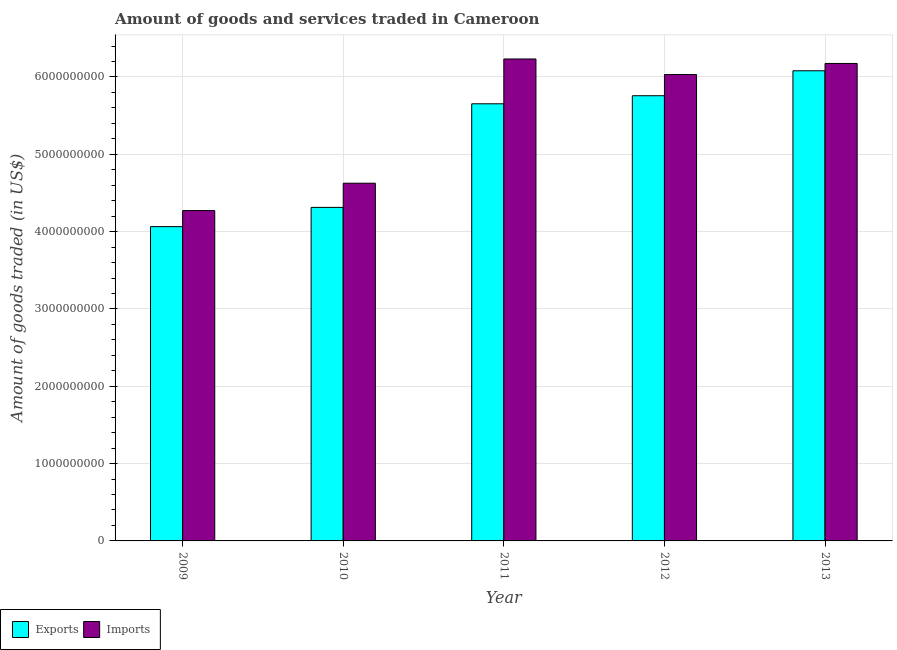How many different coloured bars are there?
Offer a terse response. 2. How many groups of bars are there?
Ensure brevity in your answer.  5. Are the number of bars per tick equal to the number of legend labels?
Your answer should be compact. Yes. Are the number of bars on each tick of the X-axis equal?
Offer a very short reply. Yes. How many bars are there on the 5th tick from the left?
Your answer should be very brief. 2. What is the label of the 2nd group of bars from the left?
Keep it short and to the point. 2010. What is the amount of goods exported in 2009?
Provide a short and direct response. 4.06e+09. Across all years, what is the maximum amount of goods imported?
Your answer should be very brief. 6.23e+09. Across all years, what is the minimum amount of goods imported?
Offer a terse response. 4.27e+09. What is the total amount of goods exported in the graph?
Offer a very short reply. 2.59e+1. What is the difference between the amount of goods imported in 2012 and that in 2013?
Provide a succinct answer. -1.43e+08. What is the difference between the amount of goods exported in 2011 and the amount of goods imported in 2009?
Provide a short and direct response. 1.59e+09. What is the average amount of goods exported per year?
Give a very brief answer. 5.17e+09. What is the ratio of the amount of goods exported in 2010 to that in 2012?
Your response must be concise. 0.75. Is the amount of goods exported in 2009 less than that in 2013?
Your answer should be very brief. Yes. What is the difference between the highest and the second highest amount of goods imported?
Provide a short and direct response. 5.81e+07. What is the difference between the highest and the lowest amount of goods exported?
Offer a very short reply. 2.02e+09. Is the sum of the amount of goods imported in 2012 and 2013 greater than the maximum amount of goods exported across all years?
Your answer should be very brief. Yes. What does the 2nd bar from the left in 2011 represents?
Your answer should be very brief. Imports. What does the 1st bar from the right in 2009 represents?
Your answer should be very brief. Imports. How many bars are there?
Keep it short and to the point. 10. What is the difference between two consecutive major ticks on the Y-axis?
Offer a terse response. 1.00e+09. Where does the legend appear in the graph?
Offer a terse response. Bottom left. What is the title of the graph?
Offer a terse response. Amount of goods and services traded in Cameroon. Does "Quality of trade" appear as one of the legend labels in the graph?
Ensure brevity in your answer.  No. What is the label or title of the Y-axis?
Make the answer very short. Amount of goods traded (in US$). What is the Amount of goods traded (in US$) of Exports in 2009?
Your answer should be compact. 4.06e+09. What is the Amount of goods traded (in US$) of Imports in 2009?
Your response must be concise. 4.27e+09. What is the Amount of goods traded (in US$) of Exports in 2010?
Make the answer very short. 4.31e+09. What is the Amount of goods traded (in US$) of Imports in 2010?
Your answer should be compact. 4.63e+09. What is the Amount of goods traded (in US$) of Exports in 2011?
Ensure brevity in your answer.  5.65e+09. What is the Amount of goods traded (in US$) of Imports in 2011?
Make the answer very short. 6.23e+09. What is the Amount of goods traded (in US$) of Exports in 2012?
Your answer should be compact. 5.76e+09. What is the Amount of goods traded (in US$) in Imports in 2012?
Your response must be concise. 6.03e+09. What is the Amount of goods traded (in US$) of Exports in 2013?
Offer a terse response. 6.08e+09. What is the Amount of goods traded (in US$) of Imports in 2013?
Offer a terse response. 6.17e+09. Across all years, what is the maximum Amount of goods traded (in US$) in Exports?
Ensure brevity in your answer.  6.08e+09. Across all years, what is the maximum Amount of goods traded (in US$) of Imports?
Give a very brief answer. 6.23e+09. Across all years, what is the minimum Amount of goods traded (in US$) in Exports?
Offer a terse response. 4.06e+09. Across all years, what is the minimum Amount of goods traded (in US$) in Imports?
Offer a terse response. 4.27e+09. What is the total Amount of goods traded (in US$) of Exports in the graph?
Offer a very short reply. 2.59e+1. What is the total Amount of goods traded (in US$) in Imports in the graph?
Provide a short and direct response. 2.73e+1. What is the difference between the Amount of goods traded (in US$) of Exports in 2009 and that in 2010?
Your response must be concise. -2.49e+08. What is the difference between the Amount of goods traded (in US$) of Imports in 2009 and that in 2010?
Ensure brevity in your answer.  -3.54e+08. What is the difference between the Amount of goods traded (in US$) of Exports in 2009 and that in 2011?
Provide a short and direct response. -1.59e+09. What is the difference between the Amount of goods traded (in US$) in Imports in 2009 and that in 2011?
Give a very brief answer. -1.96e+09. What is the difference between the Amount of goods traded (in US$) in Exports in 2009 and that in 2012?
Your answer should be very brief. -1.69e+09. What is the difference between the Amount of goods traded (in US$) of Imports in 2009 and that in 2012?
Provide a succinct answer. -1.76e+09. What is the difference between the Amount of goods traded (in US$) of Exports in 2009 and that in 2013?
Make the answer very short. -2.02e+09. What is the difference between the Amount of goods traded (in US$) of Imports in 2009 and that in 2013?
Give a very brief answer. -1.90e+09. What is the difference between the Amount of goods traded (in US$) in Exports in 2010 and that in 2011?
Your response must be concise. -1.34e+09. What is the difference between the Amount of goods traded (in US$) in Imports in 2010 and that in 2011?
Provide a succinct answer. -1.61e+09. What is the difference between the Amount of goods traded (in US$) of Exports in 2010 and that in 2012?
Provide a short and direct response. -1.44e+09. What is the difference between the Amount of goods traded (in US$) of Imports in 2010 and that in 2012?
Keep it short and to the point. -1.41e+09. What is the difference between the Amount of goods traded (in US$) in Exports in 2010 and that in 2013?
Give a very brief answer. -1.77e+09. What is the difference between the Amount of goods traded (in US$) of Imports in 2010 and that in 2013?
Give a very brief answer. -1.55e+09. What is the difference between the Amount of goods traded (in US$) of Exports in 2011 and that in 2012?
Your answer should be compact. -1.04e+08. What is the difference between the Amount of goods traded (in US$) of Imports in 2011 and that in 2012?
Give a very brief answer. 2.01e+08. What is the difference between the Amount of goods traded (in US$) of Exports in 2011 and that in 2013?
Offer a terse response. -4.27e+08. What is the difference between the Amount of goods traded (in US$) in Imports in 2011 and that in 2013?
Offer a terse response. 5.81e+07. What is the difference between the Amount of goods traded (in US$) of Exports in 2012 and that in 2013?
Your answer should be compact. -3.23e+08. What is the difference between the Amount of goods traded (in US$) of Imports in 2012 and that in 2013?
Keep it short and to the point. -1.43e+08. What is the difference between the Amount of goods traded (in US$) in Exports in 2009 and the Amount of goods traded (in US$) in Imports in 2010?
Keep it short and to the point. -5.62e+08. What is the difference between the Amount of goods traded (in US$) of Exports in 2009 and the Amount of goods traded (in US$) of Imports in 2011?
Make the answer very short. -2.17e+09. What is the difference between the Amount of goods traded (in US$) in Exports in 2009 and the Amount of goods traded (in US$) in Imports in 2012?
Keep it short and to the point. -1.97e+09. What is the difference between the Amount of goods traded (in US$) of Exports in 2009 and the Amount of goods traded (in US$) of Imports in 2013?
Keep it short and to the point. -2.11e+09. What is the difference between the Amount of goods traded (in US$) of Exports in 2010 and the Amount of goods traded (in US$) of Imports in 2011?
Give a very brief answer. -1.92e+09. What is the difference between the Amount of goods traded (in US$) of Exports in 2010 and the Amount of goods traded (in US$) of Imports in 2012?
Provide a short and direct response. -1.72e+09. What is the difference between the Amount of goods traded (in US$) in Exports in 2010 and the Amount of goods traded (in US$) in Imports in 2013?
Keep it short and to the point. -1.86e+09. What is the difference between the Amount of goods traded (in US$) in Exports in 2011 and the Amount of goods traded (in US$) in Imports in 2012?
Offer a terse response. -3.78e+08. What is the difference between the Amount of goods traded (in US$) in Exports in 2011 and the Amount of goods traded (in US$) in Imports in 2013?
Ensure brevity in your answer.  -5.21e+08. What is the difference between the Amount of goods traded (in US$) in Exports in 2012 and the Amount of goods traded (in US$) in Imports in 2013?
Your response must be concise. -4.17e+08. What is the average Amount of goods traded (in US$) of Exports per year?
Make the answer very short. 5.17e+09. What is the average Amount of goods traded (in US$) of Imports per year?
Offer a terse response. 5.47e+09. In the year 2009, what is the difference between the Amount of goods traded (in US$) in Exports and Amount of goods traded (in US$) in Imports?
Your answer should be very brief. -2.08e+08. In the year 2010, what is the difference between the Amount of goods traded (in US$) in Exports and Amount of goods traded (in US$) in Imports?
Ensure brevity in your answer.  -3.13e+08. In the year 2011, what is the difference between the Amount of goods traded (in US$) of Exports and Amount of goods traded (in US$) of Imports?
Your response must be concise. -5.80e+08. In the year 2012, what is the difference between the Amount of goods traded (in US$) in Exports and Amount of goods traded (in US$) in Imports?
Give a very brief answer. -2.74e+08. In the year 2013, what is the difference between the Amount of goods traded (in US$) of Exports and Amount of goods traded (in US$) of Imports?
Keep it short and to the point. -9.46e+07. What is the ratio of the Amount of goods traded (in US$) in Exports in 2009 to that in 2010?
Offer a terse response. 0.94. What is the ratio of the Amount of goods traded (in US$) in Imports in 2009 to that in 2010?
Ensure brevity in your answer.  0.92. What is the ratio of the Amount of goods traded (in US$) in Exports in 2009 to that in 2011?
Offer a terse response. 0.72. What is the ratio of the Amount of goods traded (in US$) of Imports in 2009 to that in 2011?
Your response must be concise. 0.69. What is the ratio of the Amount of goods traded (in US$) of Exports in 2009 to that in 2012?
Provide a succinct answer. 0.71. What is the ratio of the Amount of goods traded (in US$) of Imports in 2009 to that in 2012?
Offer a very short reply. 0.71. What is the ratio of the Amount of goods traded (in US$) in Exports in 2009 to that in 2013?
Keep it short and to the point. 0.67. What is the ratio of the Amount of goods traded (in US$) in Imports in 2009 to that in 2013?
Your answer should be very brief. 0.69. What is the ratio of the Amount of goods traded (in US$) of Exports in 2010 to that in 2011?
Give a very brief answer. 0.76. What is the ratio of the Amount of goods traded (in US$) of Imports in 2010 to that in 2011?
Offer a terse response. 0.74. What is the ratio of the Amount of goods traded (in US$) of Exports in 2010 to that in 2012?
Provide a short and direct response. 0.75. What is the ratio of the Amount of goods traded (in US$) in Imports in 2010 to that in 2012?
Provide a succinct answer. 0.77. What is the ratio of the Amount of goods traded (in US$) of Exports in 2010 to that in 2013?
Offer a terse response. 0.71. What is the ratio of the Amount of goods traded (in US$) of Imports in 2010 to that in 2013?
Your answer should be very brief. 0.75. What is the ratio of the Amount of goods traded (in US$) of Exports in 2011 to that in 2012?
Provide a short and direct response. 0.98. What is the ratio of the Amount of goods traded (in US$) in Imports in 2011 to that in 2012?
Give a very brief answer. 1.03. What is the ratio of the Amount of goods traded (in US$) of Exports in 2011 to that in 2013?
Make the answer very short. 0.93. What is the ratio of the Amount of goods traded (in US$) in Imports in 2011 to that in 2013?
Offer a terse response. 1.01. What is the ratio of the Amount of goods traded (in US$) of Exports in 2012 to that in 2013?
Make the answer very short. 0.95. What is the ratio of the Amount of goods traded (in US$) in Imports in 2012 to that in 2013?
Provide a short and direct response. 0.98. What is the difference between the highest and the second highest Amount of goods traded (in US$) of Exports?
Your response must be concise. 3.23e+08. What is the difference between the highest and the second highest Amount of goods traded (in US$) of Imports?
Ensure brevity in your answer.  5.81e+07. What is the difference between the highest and the lowest Amount of goods traded (in US$) in Exports?
Offer a terse response. 2.02e+09. What is the difference between the highest and the lowest Amount of goods traded (in US$) in Imports?
Your response must be concise. 1.96e+09. 